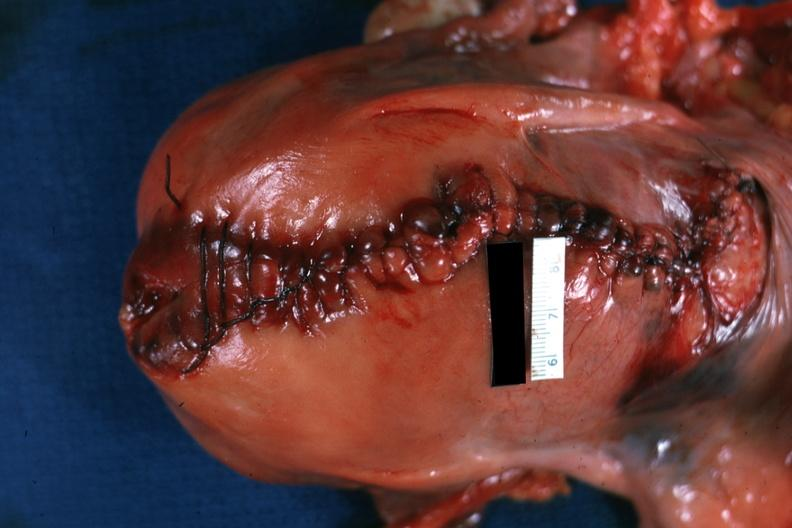what is present?
Answer the question using a single word or phrase. Uterus 